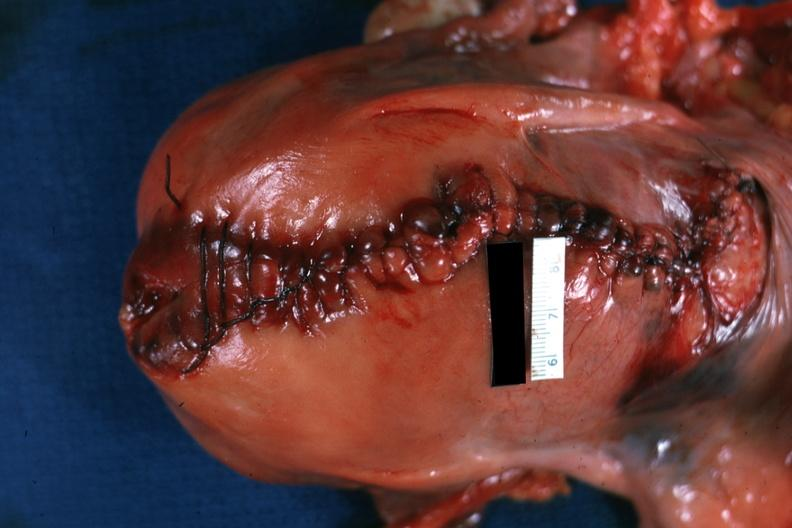what is present?
Answer the question using a single word or phrase. Uterus 